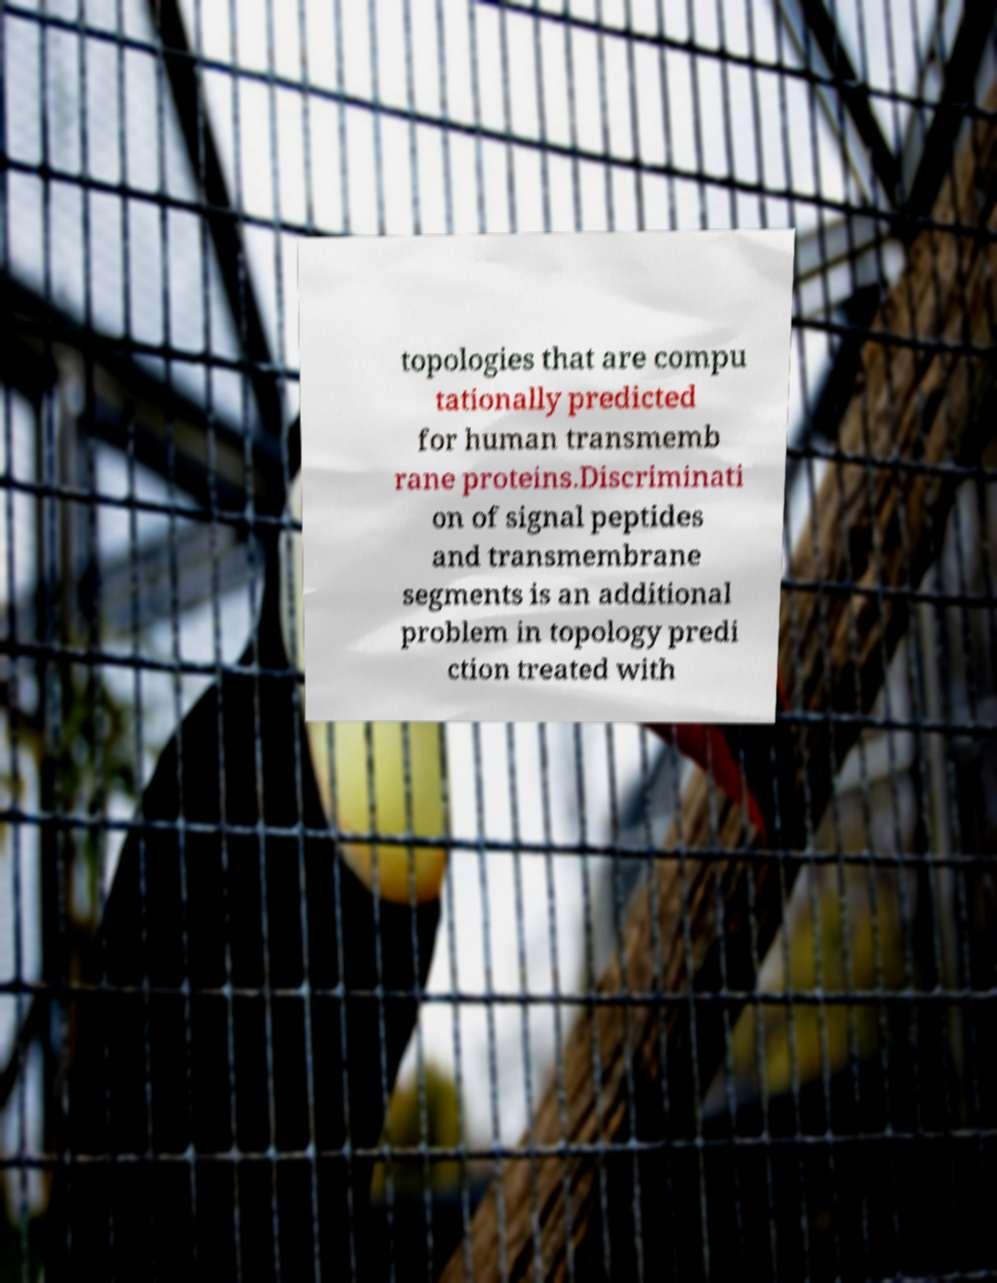Please read and relay the text visible in this image. What does it say? topologies that are compu tationally predicted for human transmemb rane proteins.Discriminati on of signal peptides and transmembrane segments is an additional problem in topology predi ction treated with 